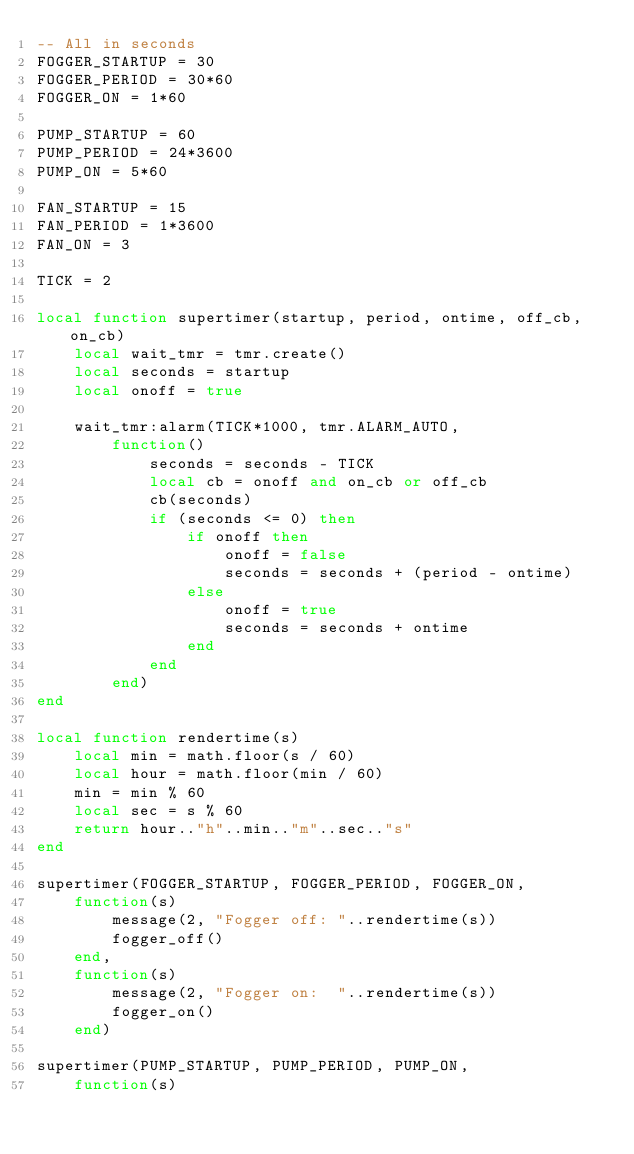<code> <loc_0><loc_0><loc_500><loc_500><_Lua_>-- All in seconds
FOGGER_STARTUP = 30
FOGGER_PERIOD = 30*60
FOGGER_ON = 1*60

PUMP_STARTUP = 60
PUMP_PERIOD = 24*3600
PUMP_ON = 5*60

FAN_STARTUP = 15
FAN_PERIOD = 1*3600
FAN_ON = 3

TICK = 2

local function supertimer(startup, period, ontime, off_cb, on_cb)
    local wait_tmr = tmr.create()
    local seconds = startup
    local onoff = true

    wait_tmr:alarm(TICK*1000, tmr.ALARM_AUTO,
        function()
            seconds = seconds - TICK
            local cb = onoff and on_cb or off_cb
            cb(seconds)
            if (seconds <= 0) then
                if onoff then
                    onoff = false
                    seconds = seconds + (period - ontime)
                else
                    onoff = true
                    seconds = seconds + ontime
                end
            end
        end)
end

local function rendertime(s)
    local min = math.floor(s / 60)
    local hour = math.floor(min / 60)
    min = min % 60
    local sec = s % 60
    return hour.."h"..min.."m"..sec.."s"
end

supertimer(FOGGER_STARTUP, FOGGER_PERIOD, FOGGER_ON,
    function(s)
        message(2, "Fogger off: "..rendertime(s))
        fogger_off()
    end,
    function(s)
        message(2, "Fogger on:  "..rendertime(s))
        fogger_on()
    end)    

supertimer(PUMP_STARTUP, PUMP_PERIOD, PUMP_ON,
    function(s)</code> 